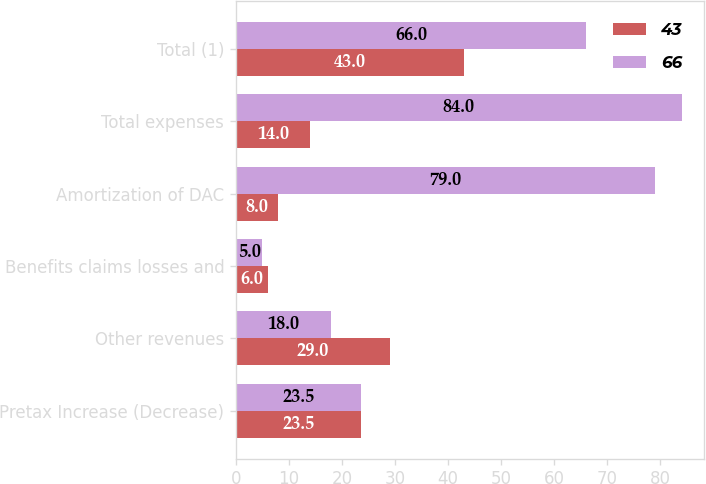<chart> <loc_0><loc_0><loc_500><loc_500><stacked_bar_chart><ecel><fcel>Pretax Increase (Decrease)<fcel>Other revenues<fcel>Benefits claims losses and<fcel>Amortization of DAC<fcel>Total expenses<fcel>Total (1)<nl><fcel>43<fcel>23.5<fcel>29<fcel>6<fcel>8<fcel>14<fcel>43<nl><fcel>66<fcel>23.5<fcel>18<fcel>5<fcel>79<fcel>84<fcel>66<nl></chart> 